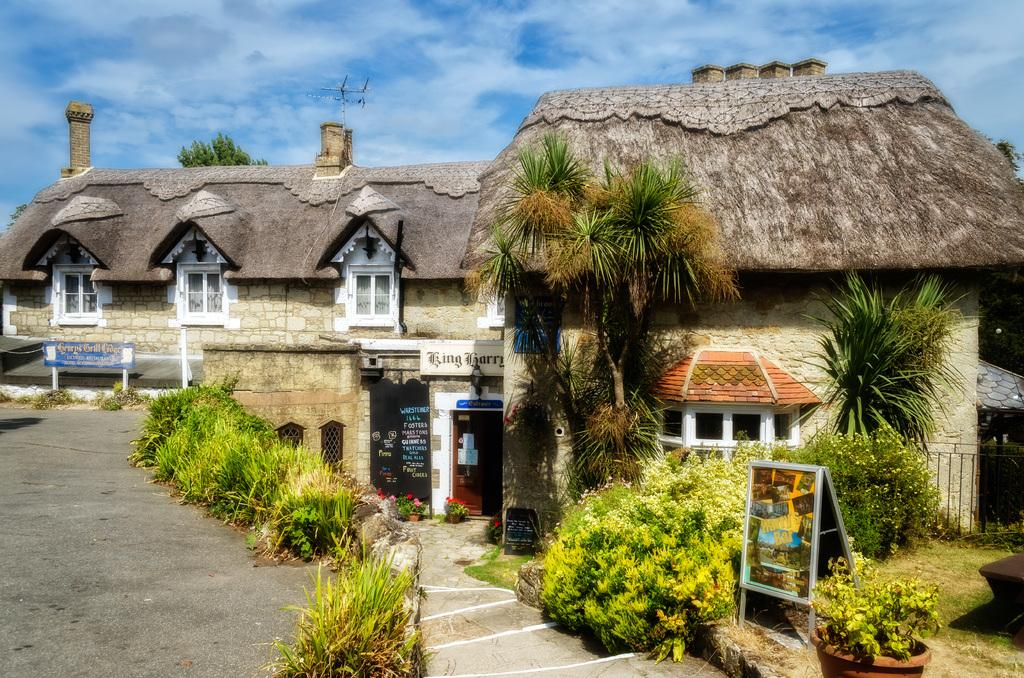What type of structures can be seen in the image? There are houses in the image. What is placed in front of the houses? There are boards and plants in front of the houses. What type of vegetation is present in front of the houses? There is grass in front of the houses. What can be seen in the background of the image? There is a tree, clouds, and the sky visible in the background of the image. What type of shoes are the houses wearing in the image? Houses do not wear shoes, as they are inanimate structures. 